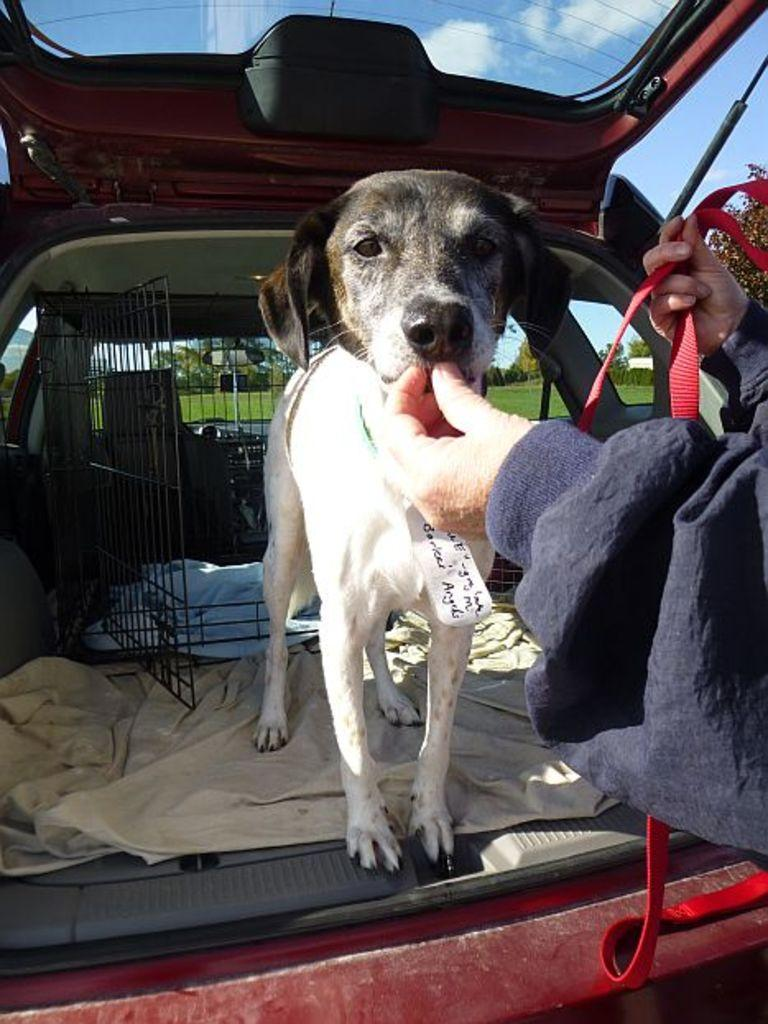What type of animal is in the image? There is a white dog in the image. What is the person in front of the dog doing? The provided facts do not specify what the person is doing. Where is the dog located in the image? The dog is standing in a red car. What is behind the dog in the image? There is a cage behind the dog. What can be seen in the background of the image? Grass and trees are visible in the background of the image. What does the thumb of the person in the image regret? There is no information about a person's thumb or any feelings of regret in the image. 